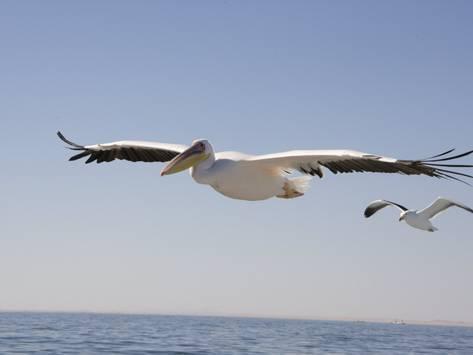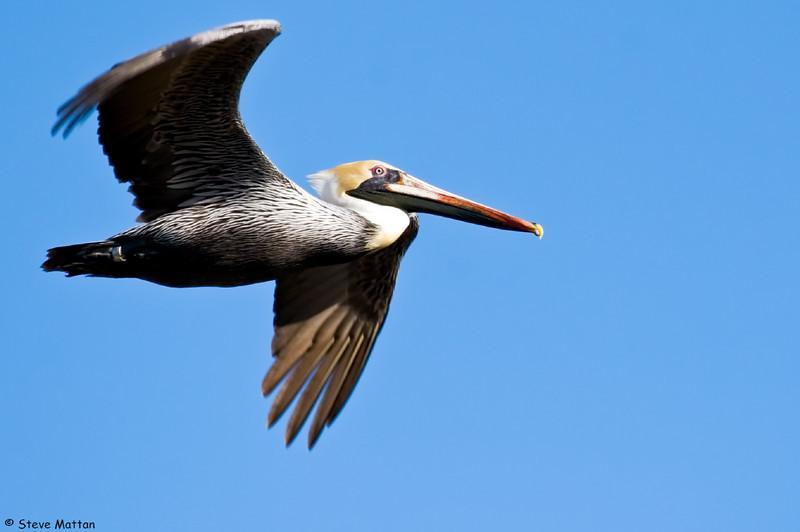The first image is the image on the left, the second image is the image on the right. For the images displayed, is the sentence "All pelicans are in flight, left and right images contain the same number of pelican-type birds, and no single image contains more than two pelicans." factually correct? Answer yes or no. Yes. The first image is the image on the left, the second image is the image on the right. For the images displayed, is the sentence "The right image contains exactly two birds flying in the sky." factually correct? Answer yes or no. No. 